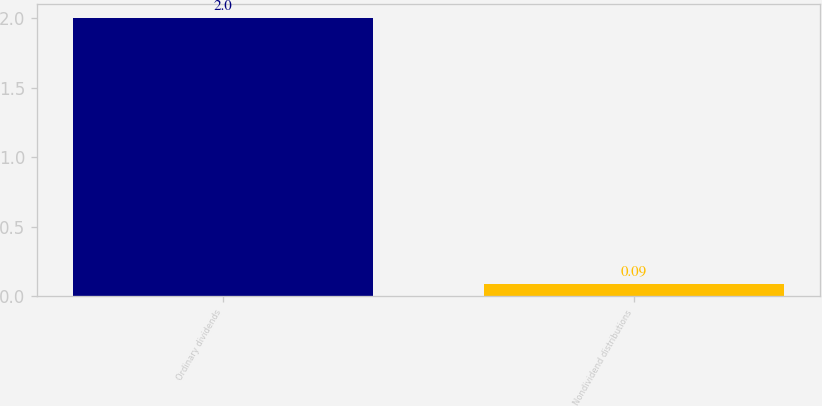Convert chart to OTSL. <chart><loc_0><loc_0><loc_500><loc_500><bar_chart><fcel>Ordinary dividends<fcel>Nondividend distributions<nl><fcel>2<fcel>0.09<nl></chart> 